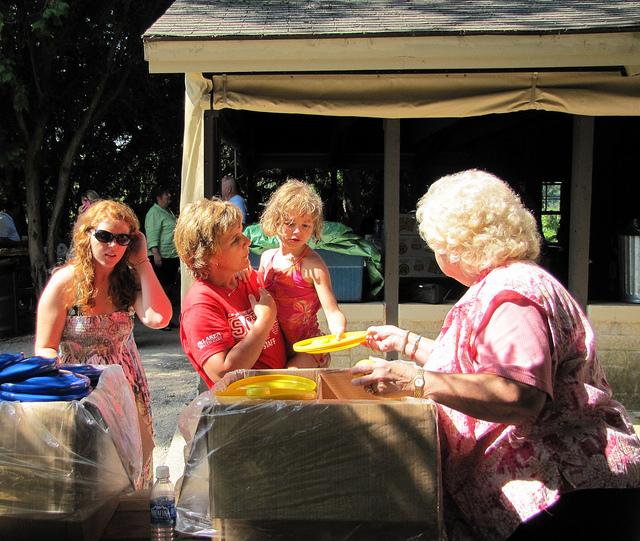Is this a man?
Short answer required. No. How many people are wearing sunglasses?
Short answer required. 1. What colors are the frisbees?
Quick response, please. Yellow and blue. 